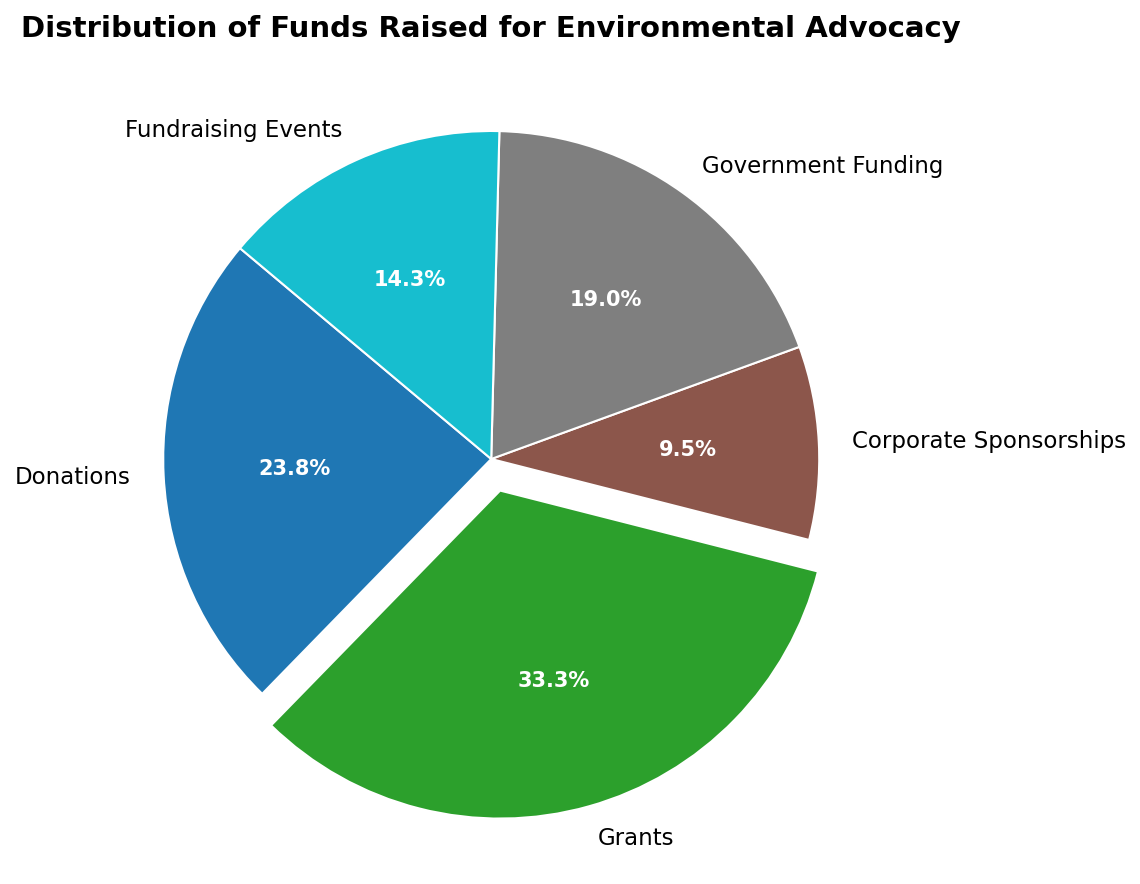What percentage of the total funds comes from Donations? Find the slice labeled "Donations" and read its percentage directly from the visualization.
Answer: 25.0% Which category received the highest amount of funds? Look for the slice with the largest area and check its label.
Answer: Grants How much more funding did Grants receive compared to Corporate Sponsorships? Subtract the amount for Corporate Sponsorships from the amount for Grants: 350,000 - 100,000 = 250,000
Answer: 250,000 What is the combined percentage of Government Funding and Fundraising Events? Add the percentages for Government Funding and Fundraising Events directly from the chart: 20.0% + 15.0% = 35.0%
Answer: 35.0% Is the amount of funding from Donations greater than from Government Funding? Compare the percentages or amounts for Donations and Government Funding. Donations (25.0%) is greater than Government Funding (20.0%).
Answer: Yes What is the visual representation (color or explosion) of the category that raised the most funds? Identify the slice labeled "Grants" and note that it's slightly separated from the rest, indicating it has an "exploded" slice. Its color is whatever color is assigned in the chart.
Answer: Exploded slice What percentage of the total funds comes from Corporate Sponsorships? Find the slice labeled "Corporate Sponsorships" and read its percentage directly from the visualization.
Answer: 10.0% How does the amount of funds from Fundraising Events compare to Government Funding? Compare the percentages or amounts for Fundraising Events and Government Funding: Fundraising Events (15.0%) is less than Government Funding (20.0%).
Answer: Less If we combine the amounts from Donations and Corporate Sponsorships, what percentage of the total funds would that represent? Sum the amounts for Donations and Corporate Sponsorships: 250,000 + 100,000 = 350,000. Calculate the percentage: (350,000 / 1,050,000) * 100 = 33.3%.
Answer: 33.3% What is the least funded category and by how much? Identify the smallest slice and check its label: Corporate Sponsorships, with 100,000.
Answer: Corporate Sponsorships, 100,000 